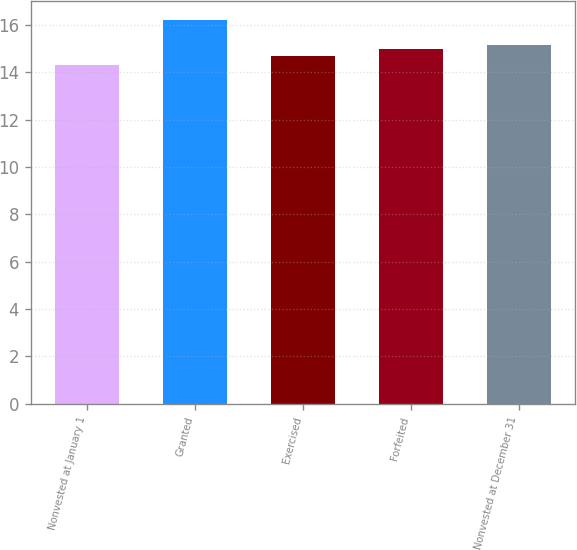<chart> <loc_0><loc_0><loc_500><loc_500><bar_chart><fcel>Nonvested at January 1<fcel>Granted<fcel>Exercised<fcel>Forfeited<fcel>Nonvested at December 31<nl><fcel>14.32<fcel>16.21<fcel>14.71<fcel>14.97<fcel>15.16<nl></chart> 